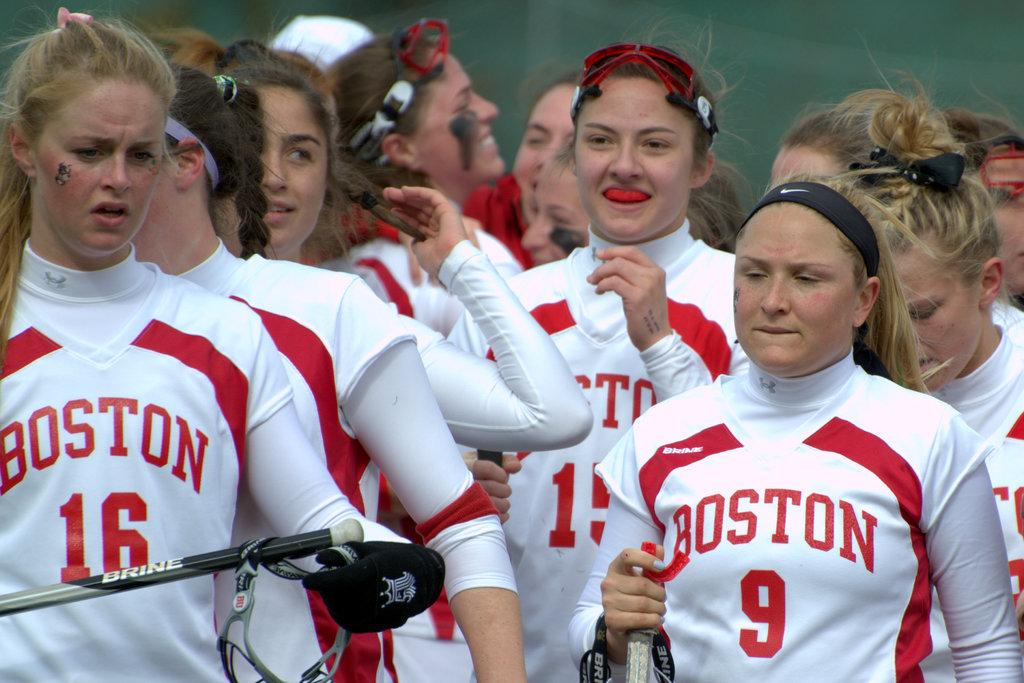<image>
Write a terse but informative summary of the picture. Athletes in white and red jersey's with Boston across the front. 